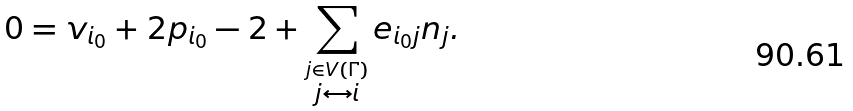<formula> <loc_0><loc_0><loc_500><loc_500>0 = v _ { i _ { 0 } } + 2 p _ { i _ { 0 } } - 2 + \sum _ { \stackrel { j \in V ( \Gamma ) } { j \leftrightarrow i } } e _ { i _ { 0 } j } n _ { j } .</formula> 